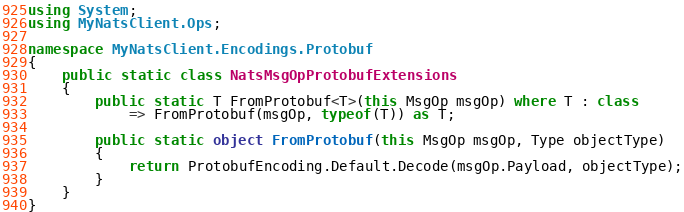Convert code to text. <code><loc_0><loc_0><loc_500><loc_500><_C#_>using System;
using MyNatsClient.Ops;

namespace MyNatsClient.Encodings.Protobuf
{
    public static class NatsMsgOpProtobufExtensions
    {
        public static T FromProtobuf<T>(this MsgOp msgOp) where T : class
            => FromProtobuf(msgOp, typeof(T)) as T;

        public static object FromProtobuf(this MsgOp msgOp, Type objectType)
        {
            return ProtobufEncoding.Default.Decode(msgOp.Payload, objectType);
        }
    }
}</code> 